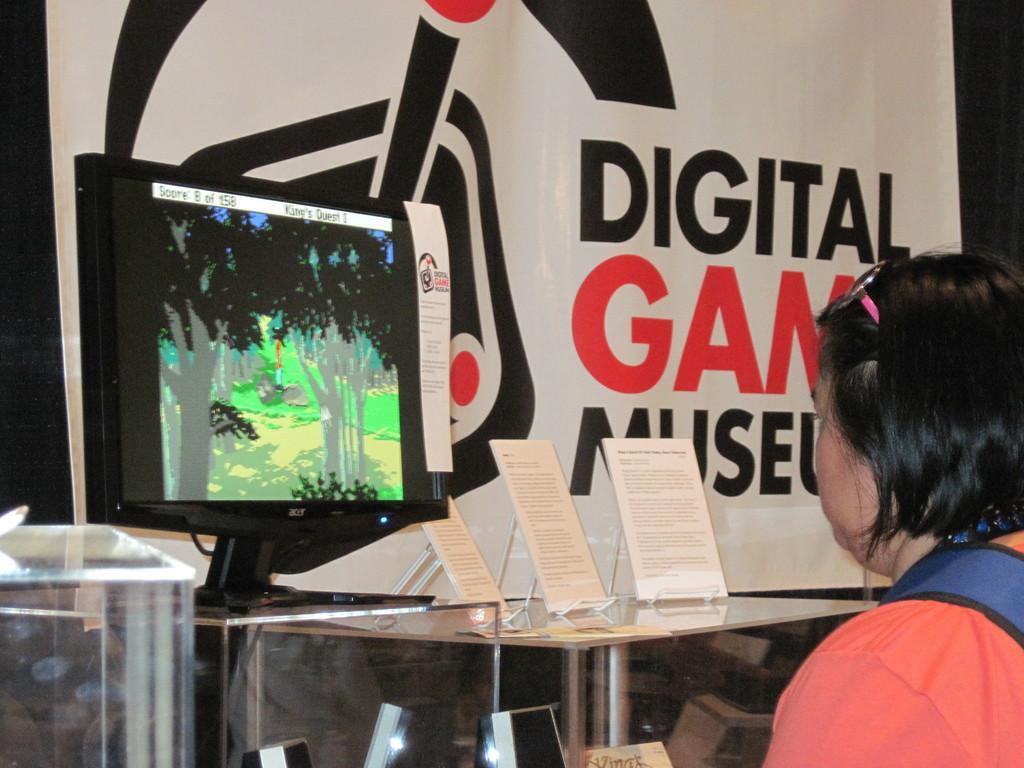In one or two sentences, can you explain what this image depicts? In this picture we can see a woman sitting in front of the system which is on the table and some boards are placed on it, behind we can see a banner. 